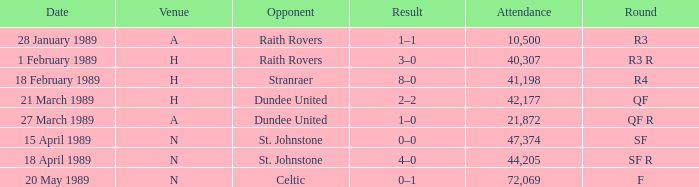What is the date when the round is qf? 21 March 1989. 